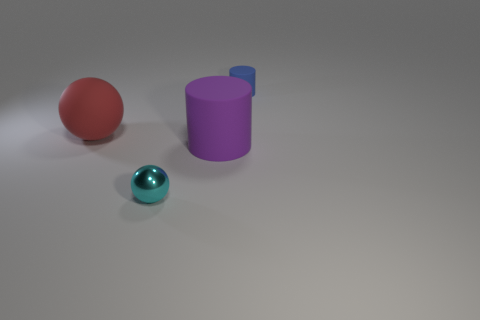If you had to guess, what material could the floor be made of? The floor presents a smooth surface with a slight reflection, indicating it could be made of a polished material, such as laminated wood, treated concrete, or a synthetic compound. The neutral tone and lack of texture suggest it is designed to complement the objects without drawing attention away from them. 